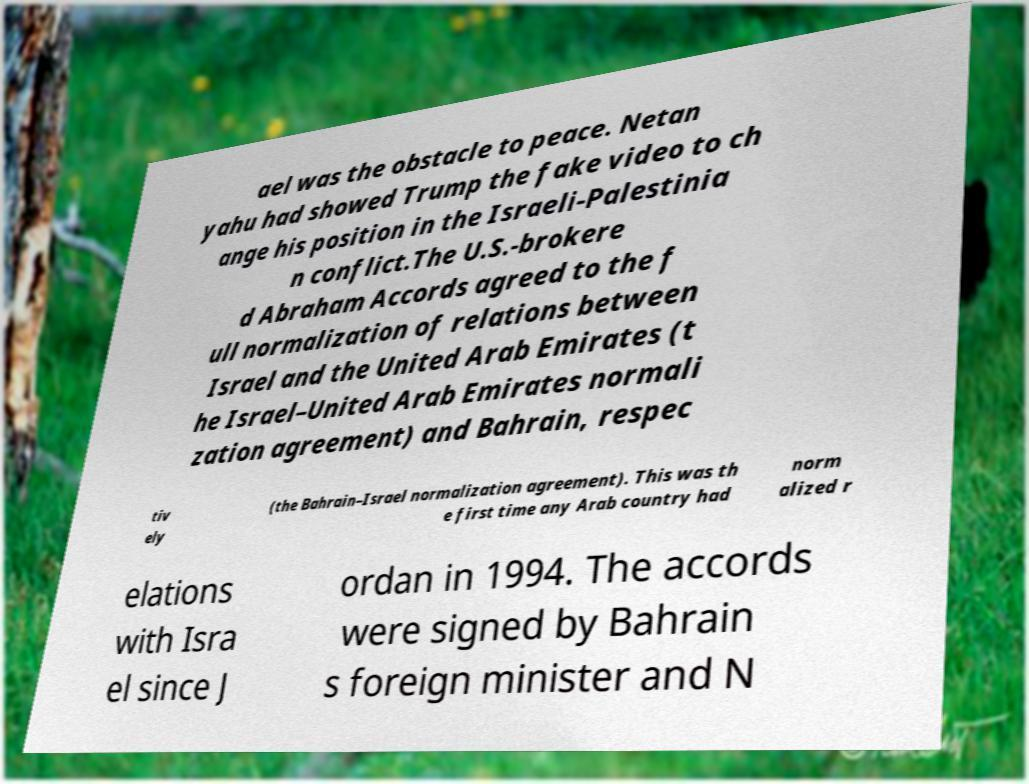Could you extract and type out the text from this image? ael was the obstacle to peace. Netan yahu had showed Trump the fake video to ch ange his position in the Israeli-Palestinia n conflict.The U.S.-brokere d Abraham Accords agreed to the f ull normalization of relations between Israel and the United Arab Emirates (t he Israel–United Arab Emirates normali zation agreement) and Bahrain, respec tiv ely (the Bahrain–Israel normalization agreement). This was th e first time any Arab country had norm alized r elations with Isra el since J ordan in 1994. The accords were signed by Bahrain s foreign minister and N 